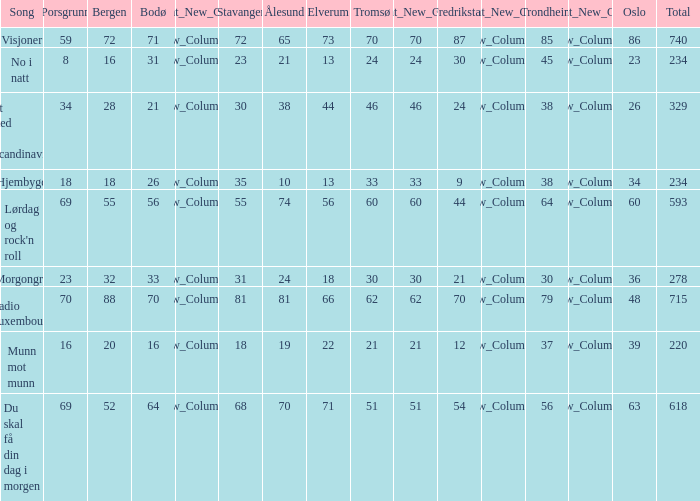When the total score is 740, what is tromso? 70.0. 